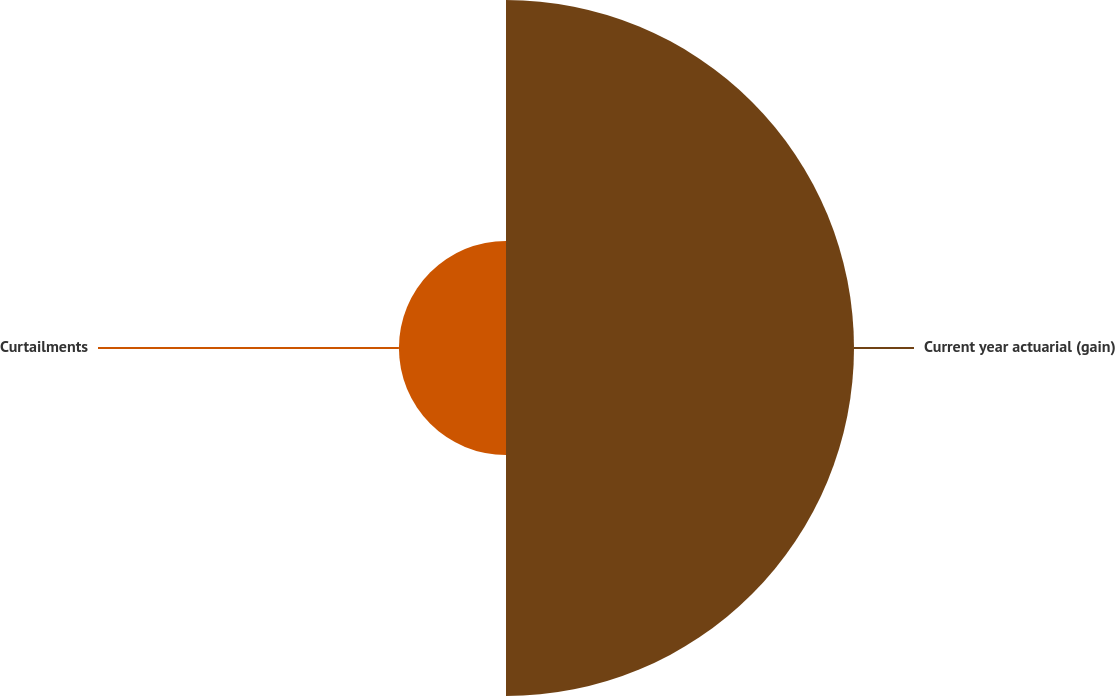Convert chart to OTSL. <chart><loc_0><loc_0><loc_500><loc_500><pie_chart><fcel>Current year actuarial (gain)<fcel>Curtailments<nl><fcel>76.47%<fcel>23.53%<nl></chart> 